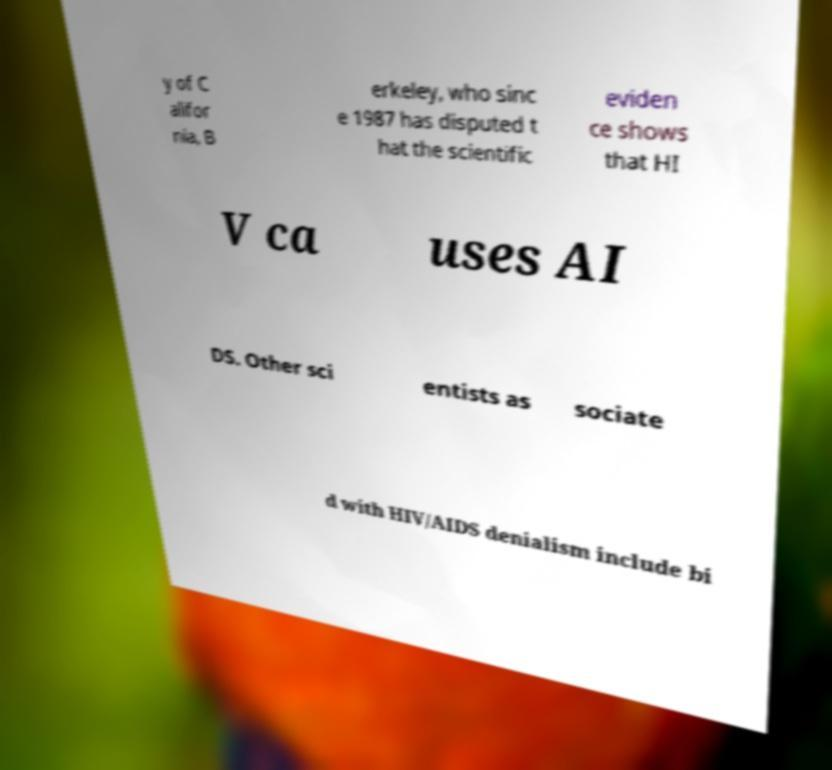Can you read and provide the text displayed in the image?This photo seems to have some interesting text. Can you extract and type it out for me? y of C alifor nia, B erkeley, who sinc e 1987 has disputed t hat the scientific eviden ce shows that HI V ca uses AI DS. Other sci entists as sociate d with HIV/AIDS denialism include bi 